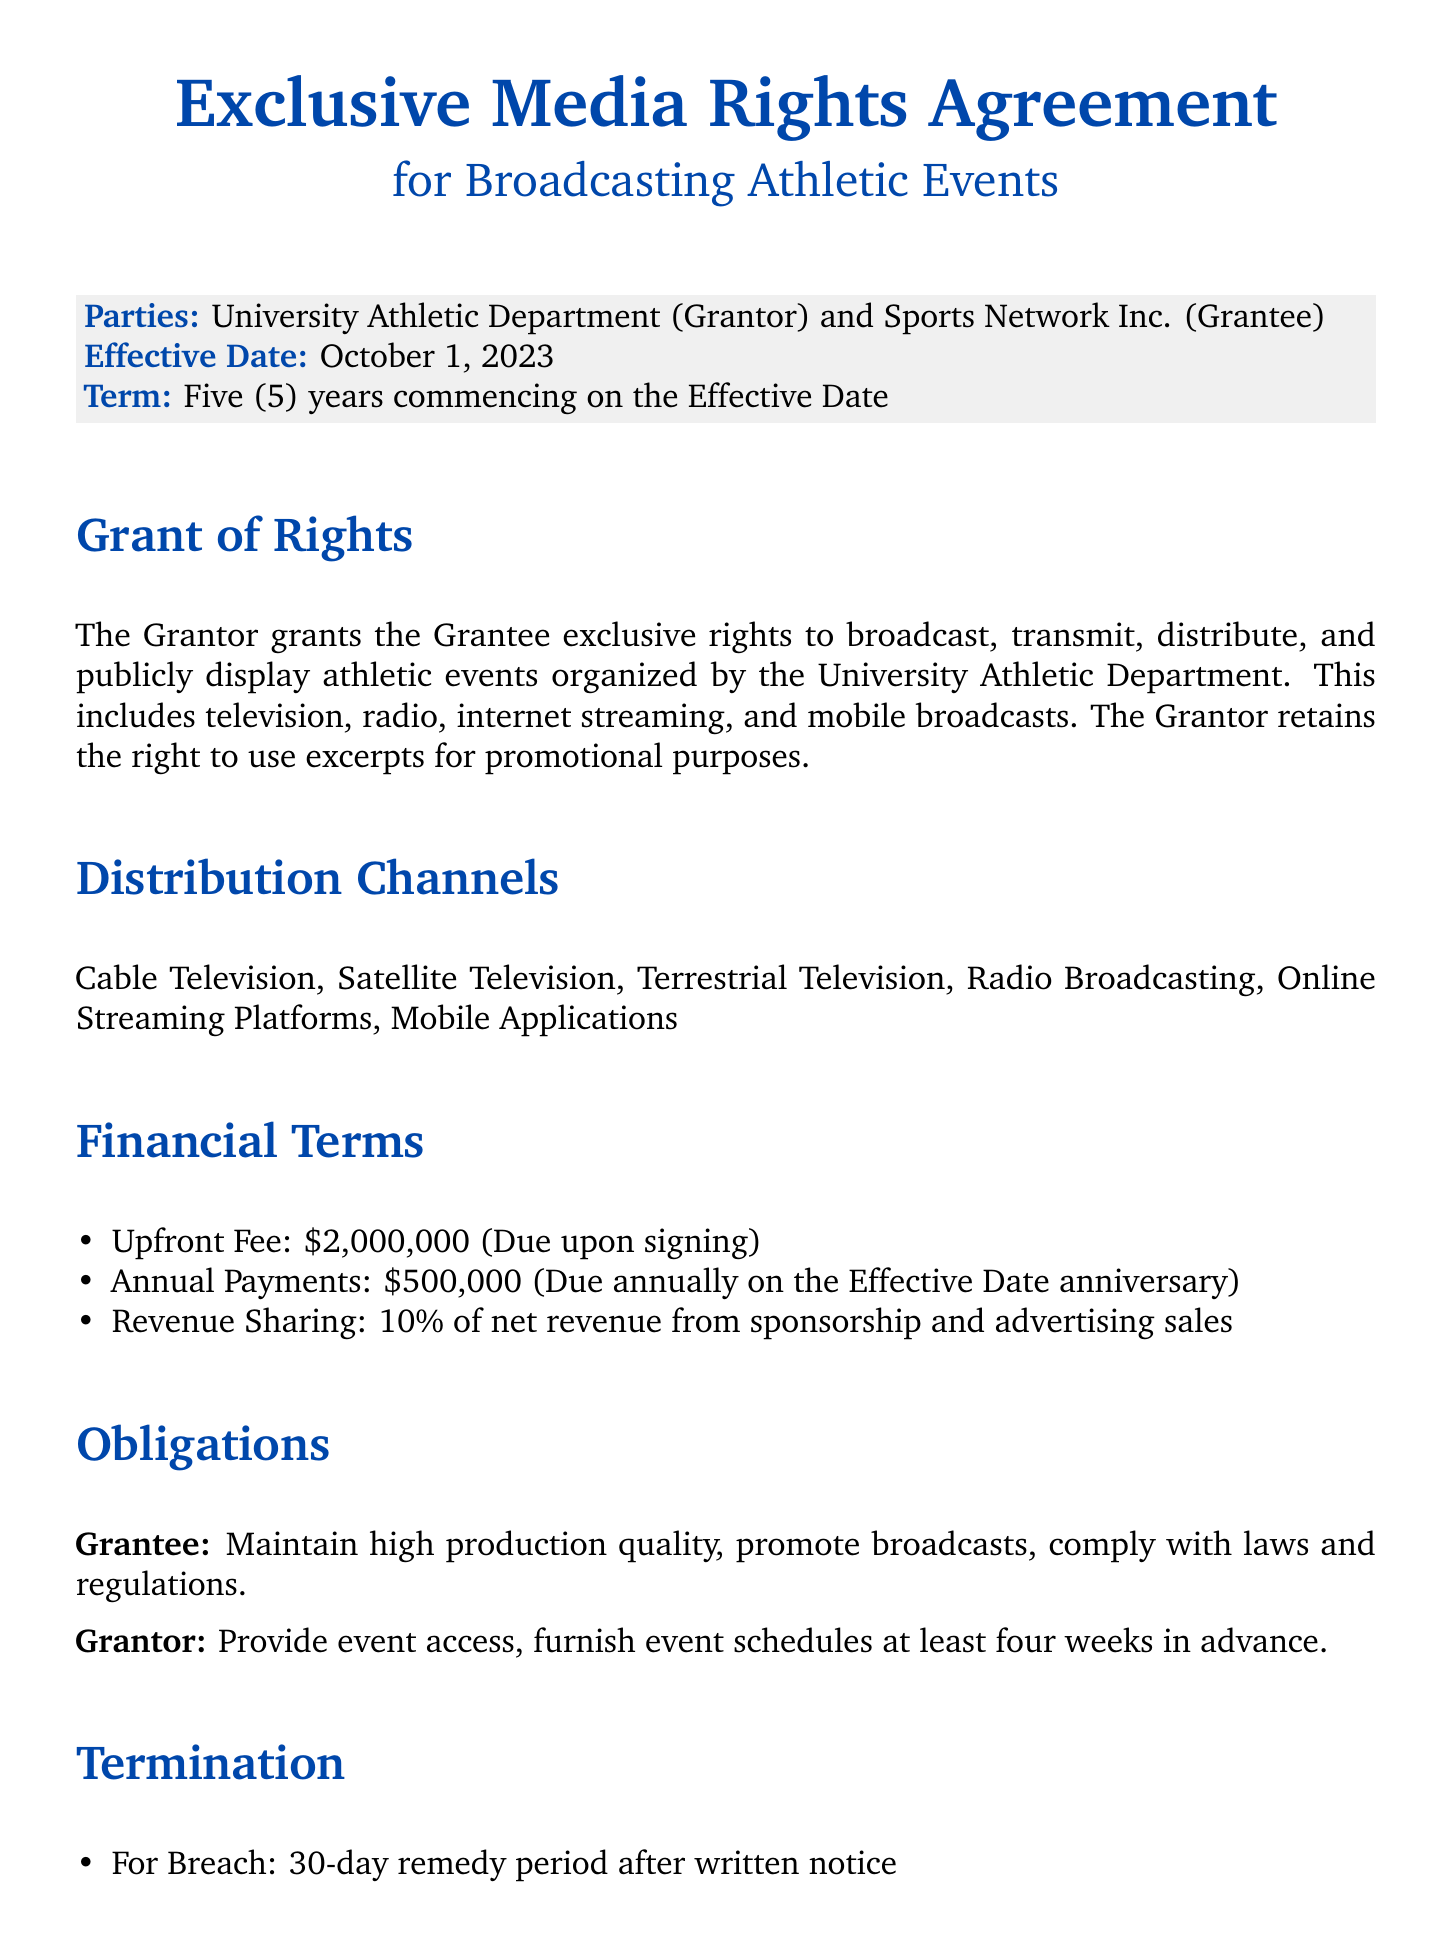What is the grantor's name? The grantor is identified as the University Athletic Department in the document.
Answer: University Athletic Department What is the upfront fee amount? The document specifies that the upfront fee due upon signing is $2,000,000.
Answer: $2,000,000 What is the duration of the term? The term of the contract is explicitly stated to be five years commencing on the effective date.
Answer: Five years Which distribution channel is included? The document lists several channels, including Cable Television and Online Streaming Platforms.
Answer: Cable Television What percentage is the revenue sharing? The document indicates that the revenue sharing percentage for sponsorship and advertising sales is 10%.
Answer: 10% What happens in case of a breach? The document states that there is a 30-day remedy period after written notice if there is a breach.
Answer: 30-day remedy period What is the governing law stated in the contract? The governing law for this agreement is specified as the State of New York.
Answer: State of New York What is the annual payment amount? The contract specifies annual payments of $500,000 due annually on the effective date anniversary.
Answer: $500,000 